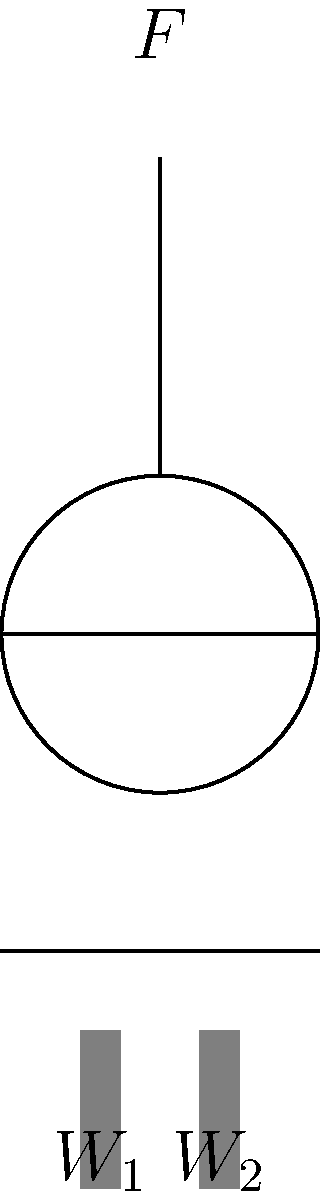In your community's fishing industry, a simple pulley system is used to lift heavy loads. If the weight $W_1$ is 100 kg and the weight $W_2$ is 80 kg, what is the minimum force $F$ required to lift the system, assuming the pulley is frictionless and the rope is massless? Express your answer in Newtons (N), using $g = 9.8$ m/s². To solve this problem, we'll follow these steps:

1) In a frictionless pulley system, the tension in the rope is constant throughout.

2) The force $F$ applied at the top must balance the combined weight of $W_1$ and $W_2$.

3) Convert the masses to forces:
   $W_1 = 100 \text{ kg} \times 9.8 \text{ m/s²} = 980 \text{ N}$
   $W_2 = 80 \text{ kg} \times 9.8 \text{ m/s²} = 784 \text{ N}$

4) The total downward force is:
   $F_{down} = 980 \text{ N} + 784 \text{ N} = 1764 \text{ N}$

5) In equilibrium, the upward force $F$ must equal the downward force:
   $F = 1764 \text{ N}$

Therefore, a minimum force of 1764 N is required to lift the system.
Answer: 1764 N 